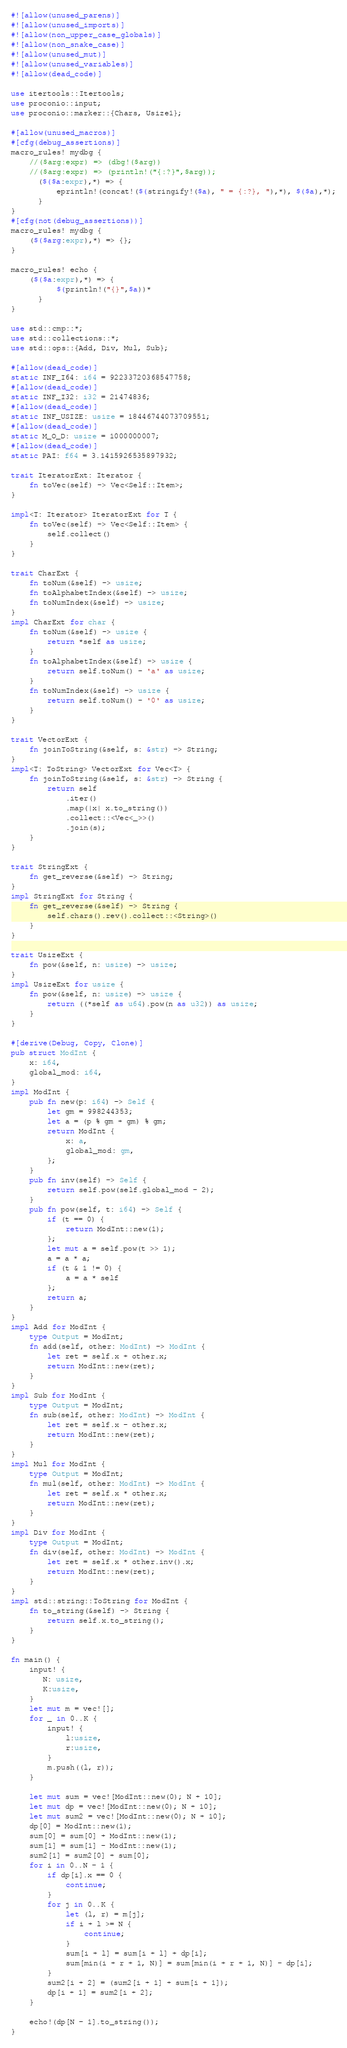<code> <loc_0><loc_0><loc_500><loc_500><_Rust_>#![allow(unused_parens)]
#![allow(unused_imports)]
#![allow(non_upper_case_globals)]
#![allow(non_snake_case)]
#![allow(unused_mut)]
#![allow(unused_variables)]
#![allow(dead_code)]

use itertools::Itertools;
use proconio::input;
use proconio::marker::{Chars, Usize1};

#[allow(unused_macros)]
#[cfg(debug_assertions)]
macro_rules! mydbg {
    //($arg:expr) => (dbg!($arg))
    //($arg:expr) => (println!("{:?}",$arg));
      ($($a:expr),*) => {
          eprintln!(concat!($(stringify!($a), " = {:?}, "),*), $($a),*);
      }
}
#[cfg(not(debug_assertions))]
macro_rules! mydbg {
    ($($arg:expr),*) => {};
}

macro_rules! echo {
    ($($a:expr),*) => {
          $(println!("{}",$a))*
      }
}

use std::cmp::*;
use std::collections::*;
use std::ops::{Add, Div, Mul, Sub};

#[allow(dead_code)]
static INF_I64: i64 = 92233720368547758;
#[allow(dead_code)]
static INF_I32: i32 = 21474836;
#[allow(dead_code)]
static INF_USIZE: usize = 18446744073709551;
#[allow(dead_code)]
static M_O_D: usize = 1000000007;
#[allow(dead_code)]
static PAI: f64 = 3.1415926535897932;

trait IteratorExt: Iterator {
    fn toVec(self) -> Vec<Self::Item>;
}

impl<T: Iterator> IteratorExt for T {
    fn toVec(self) -> Vec<Self::Item> {
        self.collect()
    }
}

trait CharExt {
    fn toNum(&self) -> usize;
    fn toAlphabetIndex(&self) -> usize;
    fn toNumIndex(&self) -> usize;
}
impl CharExt for char {
    fn toNum(&self) -> usize {
        return *self as usize;
    }
    fn toAlphabetIndex(&self) -> usize {
        return self.toNum() - 'a' as usize;
    }
    fn toNumIndex(&self) -> usize {
        return self.toNum() - '0' as usize;
    }
}

trait VectorExt {
    fn joinToString(&self, s: &str) -> String;
}
impl<T: ToString> VectorExt for Vec<T> {
    fn joinToString(&self, s: &str) -> String {
        return self
            .iter()
            .map(|x| x.to_string())
            .collect::<Vec<_>>()
            .join(s);
    }
}

trait StringExt {
    fn get_reverse(&self) -> String;
}
impl StringExt for String {
    fn get_reverse(&self) -> String {
        self.chars().rev().collect::<String>()
    }
}

trait UsizeExt {
    fn pow(&self, n: usize) -> usize;
}
impl UsizeExt for usize {
    fn pow(&self, n: usize) -> usize {
        return ((*self as u64).pow(n as u32)) as usize;
    }
}

#[derive(Debug, Copy, Clone)]
pub struct ModInt {
    x: i64,
    global_mod: i64,
}
impl ModInt {
    pub fn new(p: i64) -> Self {
        let gm = 998244353;
        let a = (p % gm + gm) % gm;
        return ModInt {
            x: a,
            global_mod: gm,
        };
    }
    pub fn inv(self) -> Self {
        return self.pow(self.global_mod - 2);
    }
    pub fn pow(self, t: i64) -> Self {
        if (t == 0) {
            return ModInt::new(1);
        };
        let mut a = self.pow(t >> 1);
        a = a * a;
        if (t & 1 != 0) {
            a = a * self
        };
        return a;
    }
}
impl Add for ModInt {
    type Output = ModInt;
    fn add(self, other: ModInt) -> ModInt {
        let ret = self.x + other.x;
        return ModInt::new(ret);
    }
}
impl Sub for ModInt {
    type Output = ModInt;
    fn sub(self, other: ModInt) -> ModInt {
        let ret = self.x - other.x;
        return ModInt::new(ret);
    }
}
impl Mul for ModInt {
    type Output = ModInt;
    fn mul(self, other: ModInt) -> ModInt {
        let ret = self.x * other.x;
        return ModInt::new(ret);
    }
}
impl Div for ModInt {
    type Output = ModInt;
    fn div(self, other: ModInt) -> ModInt {
        let ret = self.x * other.inv().x;
        return ModInt::new(ret);
    }
}
impl std::string::ToString for ModInt {
    fn to_string(&self) -> String {
        return self.x.to_string();
    }
}

fn main() {
    input! {
       N: usize,
       K:usize,
    }
    let mut m = vec![];
    for _ in 0..K {
        input! {
            l:usize,
            r:usize,
        }
        m.push((l, r));
    }

    let mut sum = vec![ModInt::new(0); N + 10];
    let mut dp = vec![ModInt::new(0); N + 10];
    let mut sum2 = vec![ModInt::new(0); N + 10];
    dp[0] = ModInt::new(1);
    sum[0] = sum[0] + ModInt::new(1);
    sum[1] = sum[1] - ModInt::new(1);
    sum2[1] = sum2[0] + sum[0];
    for i in 0..N - 1 {
        if dp[i].x == 0 {
            continue;
        }
        for j in 0..K {
            let (l, r) = m[j];
            if i + l >= N {
                continue;
            }
            sum[i + l] = sum[i + l] + dp[i];
            sum[min(i + r + 1, N)] = sum[min(i + r + 1, N)] - dp[i];
        }
        sum2[i + 2] = (sum2[i + 1] + sum[i + 1]);
        dp[i + 1] = sum2[i + 2];
    }

    echo!(dp[N - 1].to_string());
}
</code> 